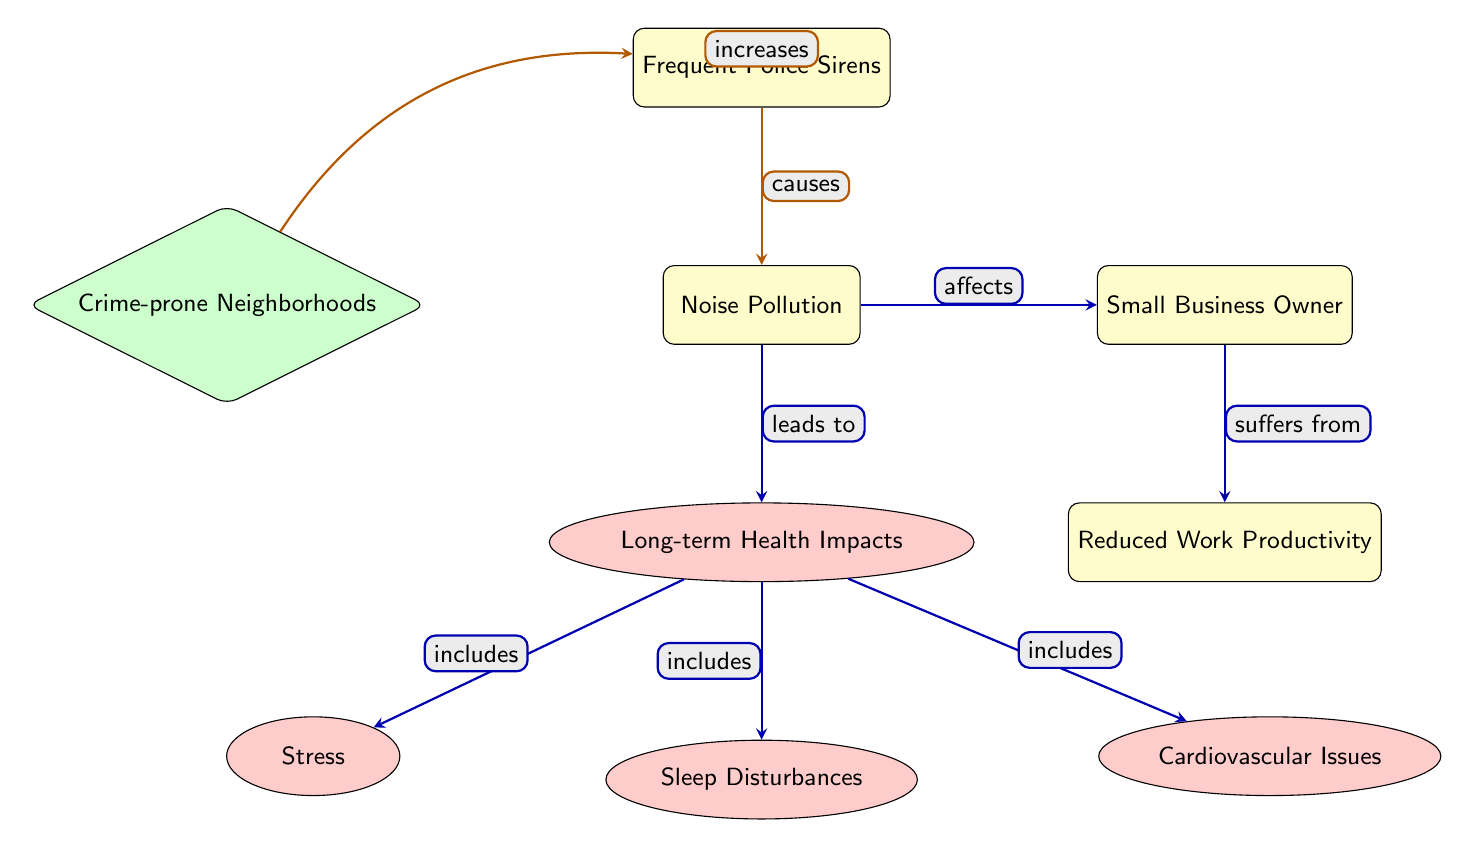What causes noise pollution? The diagram indicates that "Frequent Police Sirens" causes "Noise Pollution." This is represented by an arrow labeled "causes" from the "Frequent Police Sirens" node to the "Noise Pollution" node.
Answer: Frequent Police Sirens What are the long-term health impacts listed in the diagram? The diagram outlines three specific long-term health impacts that result from "Noise Pollution." These impacts are connected to the "Long-term Health Impacts" node, which includes "Stress," "Sleep Disturbances," and "Cardiovascular Issues," each represented by arrows labeled "includes."
Answer: Stress, Sleep Disturbances, Cardiovascular Issues How do noise pollution and crime-prone neighborhoods relate to police sirens? The diagram illustrates that "Crime-prone Neighborhoods" increases "Frequent Police Sirens," denoted by an arrow labeled "increases." This indicates a relationship where crime in the area leads to greater police presence and, consequently, more frequent sirens.
Answer: Increases What effect does noise pollution have on small business owners? The diagram specifies that "Noise Pollution" affects "Small Business Owner," represented by an arrow labeled "affects." This shows that the noise pollution impacts the small business owner directly in some way, though the specific effects are noted in another part of the diagram.
Answer: Affects What is the relationship between long-term health impacts and sleep disturbances? The diagram connects "Long-term Health Impacts" to "Sleep Disturbances" through an arrow labeled "includes." This indicates that sleep disturbances are one of the various long-term health impacts caused by noise pollution.
Answer: Includes 